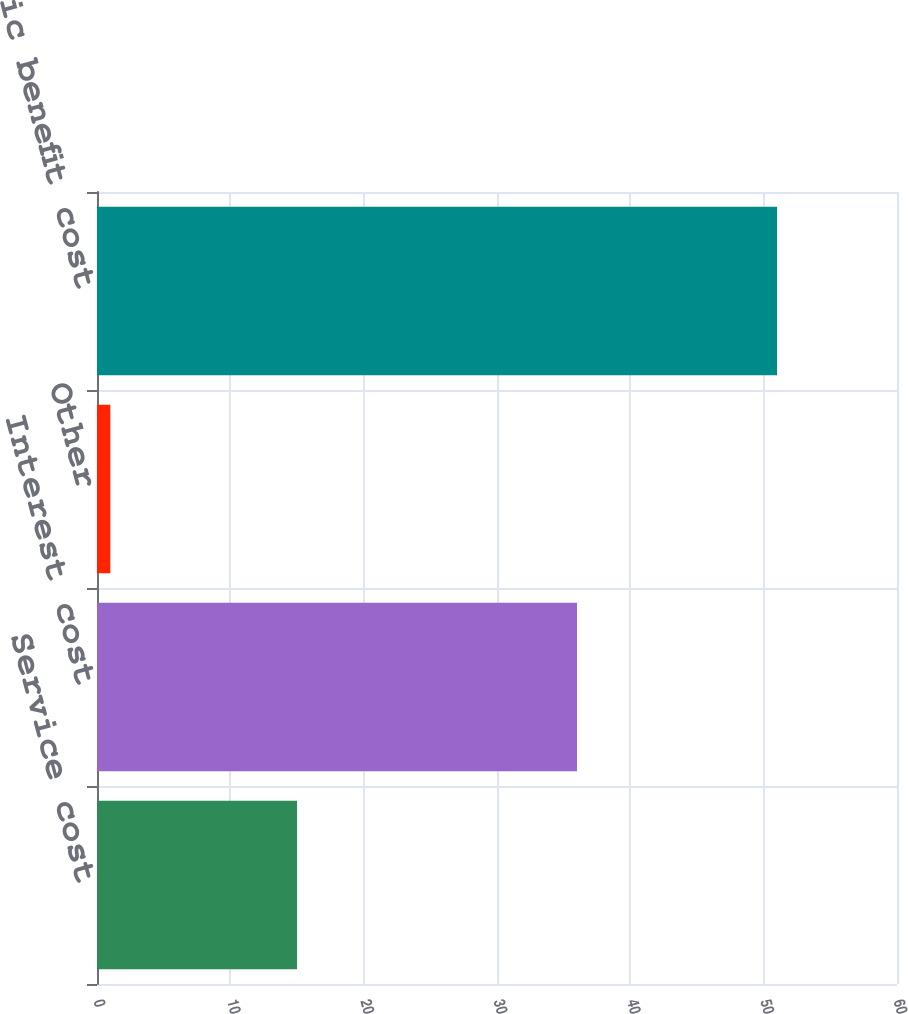Convert chart to OTSL. <chart><loc_0><loc_0><loc_500><loc_500><bar_chart><fcel>Service cost<fcel>Interest cost<fcel>Other<fcel>Net periodic benefit cost<nl><fcel>15<fcel>36<fcel>1<fcel>51<nl></chart> 